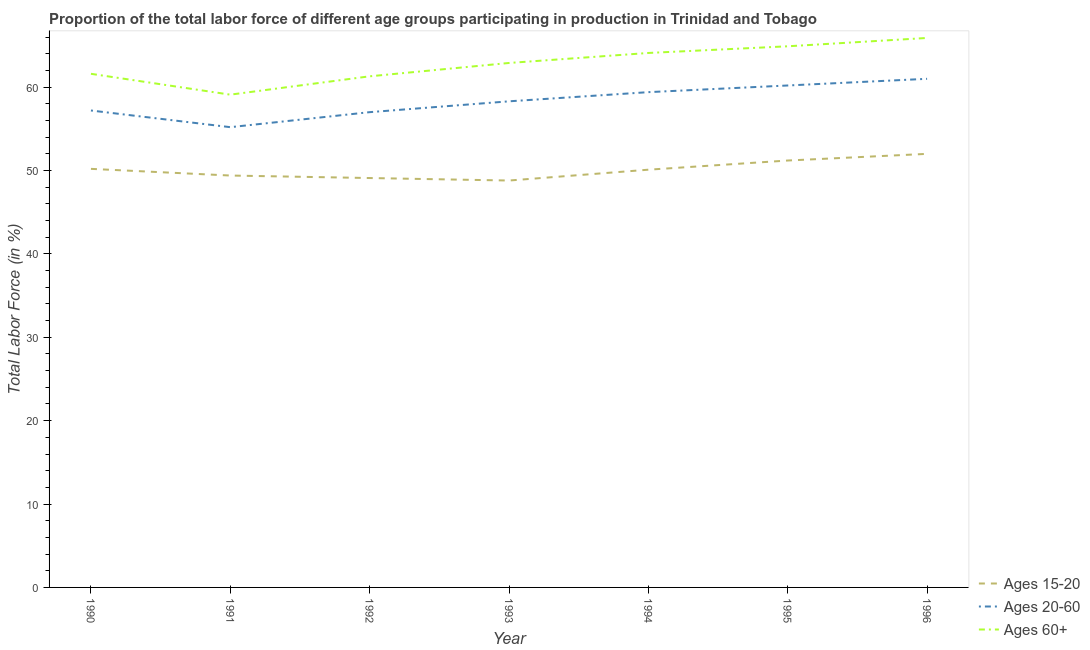How many different coloured lines are there?
Ensure brevity in your answer.  3. Does the line corresponding to percentage of labor force within the age group 20-60 intersect with the line corresponding to percentage of labor force above age 60?
Ensure brevity in your answer.  No. What is the percentage of labor force above age 60 in 1996?
Ensure brevity in your answer.  65.9. Across all years, what is the maximum percentage of labor force within the age group 20-60?
Your answer should be very brief. 61. Across all years, what is the minimum percentage of labor force above age 60?
Give a very brief answer. 59.1. In which year was the percentage of labor force within the age group 15-20 maximum?
Offer a terse response. 1996. What is the total percentage of labor force within the age group 15-20 in the graph?
Offer a very short reply. 350.8. What is the difference between the percentage of labor force within the age group 20-60 in 1995 and the percentage of labor force above age 60 in 1994?
Your response must be concise. -3.9. What is the average percentage of labor force within the age group 20-60 per year?
Provide a succinct answer. 58.33. In the year 1994, what is the difference between the percentage of labor force within the age group 15-20 and percentage of labor force above age 60?
Provide a short and direct response. -14. In how many years, is the percentage of labor force within the age group 15-20 greater than 36 %?
Offer a very short reply. 7. What is the ratio of the percentage of labor force within the age group 20-60 in 1991 to that in 1995?
Your answer should be compact. 0.92. Is the percentage of labor force within the age group 15-20 in 1990 less than that in 1991?
Keep it short and to the point. No. Is the difference between the percentage of labor force within the age group 20-60 in 1992 and 1995 greater than the difference between the percentage of labor force within the age group 15-20 in 1992 and 1995?
Provide a succinct answer. No. What is the difference between the highest and the second highest percentage of labor force above age 60?
Provide a succinct answer. 1. What is the difference between the highest and the lowest percentage of labor force within the age group 15-20?
Offer a very short reply. 3.2. Is the percentage of labor force within the age group 20-60 strictly less than the percentage of labor force within the age group 15-20 over the years?
Offer a terse response. No. How many years are there in the graph?
Your answer should be compact. 7. What is the difference between two consecutive major ticks on the Y-axis?
Offer a terse response. 10. Where does the legend appear in the graph?
Keep it short and to the point. Bottom right. How are the legend labels stacked?
Provide a short and direct response. Vertical. What is the title of the graph?
Offer a terse response. Proportion of the total labor force of different age groups participating in production in Trinidad and Tobago. What is the label or title of the X-axis?
Keep it short and to the point. Year. What is the Total Labor Force (in %) of Ages 15-20 in 1990?
Your answer should be very brief. 50.2. What is the Total Labor Force (in %) of Ages 20-60 in 1990?
Make the answer very short. 57.2. What is the Total Labor Force (in %) of Ages 60+ in 1990?
Offer a very short reply. 61.6. What is the Total Labor Force (in %) in Ages 15-20 in 1991?
Your response must be concise. 49.4. What is the Total Labor Force (in %) in Ages 20-60 in 1991?
Make the answer very short. 55.2. What is the Total Labor Force (in %) of Ages 60+ in 1991?
Provide a short and direct response. 59.1. What is the Total Labor Force (in %) of Ages 15-20 in 1992?
Give a very brief answer. 49.1. What is the Total Labor Force (in %) of Ages 60+ in 1992?
Keep it short and to the point. 61.3. What is the Total Labor Force (in %) of Ages 15-20 in 1993?
Ensure brevity in your answer.  48.8. What is the Total Labor Force (in %) in Ages 20-60 in 1993?
Offer a terse response. 58.3. What is the Total Labor Force (in %) in Ages 60+ in 1993?
Your answer should be compact. 62.9. What is the Total Labor Force (in %) of Ages 15-20 in 1994?
Offer a terse response. 50.1. What is the Total Labor Force (in %) of Ages 20-60 in 1994?
Make the answer very short. 59.4. What is the Total Labor Force (in %) in Ages 60+ in 1994?
Your answer should be very brief. 64.1. What is the Total Labor Force (in %) in Ages 15-20 in 1995?
Ensure brevity in your answer.  51.2. What is the Total Labor Force (in %) of Ages 20-60 in 1995?
Ensure brevity in your answer.  60.2. What is the Total Labor Force (in %) in Ages 60+ in 1995?
Make the answer very short. 64.9. What is the Total Labor Force (in %) in Ages 15-20 in 1996?
Provide a short and direct response. 52. What is the Total Labor Force (in %) of Ages 20-60 in 1996?
Offer a very short reply. 61. What is the Total Labor Force (in %) of Ages 60+ in 1996?
Make the answer very short. 65.9. Across all years, what is the maximum Total Labor Force (in %) in Ages 60+?
Your response must be concise. 65.9. Across all years, what is the minimum Total Labor Force (in %) of Ages 15-20?
Offer a terse response. 48.8. Across all years, what is the minimum Total Labor Force (in %) of Ages 20-60?
Give a very brief answer. 55.2. Across all years, what is the minimum Total Labor Force (in %) in Ages 60+?
Keep it short and to the point. 59.1. What is the total Total Labor Force (in %) in Ages 15-20 in the graph?
Provide a short and direct response. 350.8. What is the total Total Labor Force (in %) of Ages 20-60 in the graph?
Keep it short and to the point. 408.3. What is the total Total Labor Force (in %) of Ages 60+ in the graph?
Provide a short and direct response. 439.8. What is the difference between the Total Labor Force (in %) of Ages 15-20 in 1990 and that in 1991?
Offer a very short reply. 0.8. What is the difference between the Total Labor Force (in %) of Ages 20-60 in 1990 and that in 1991?
Offer a terse response. 2. What is the difference between the Total Labor Force (in %) in Ages 60+ in 1990 and that in 1991?
Provide a short and direct response. 2.5. What is the difference between the Total Labor Force (in %) of Ages 15-20 in 1990 and that in 1992?
Your answer should be compact. 1.1. What is the difference between the Total Labor Force (in %) of Ages 20-60 in 1990 and that in 1992?
Offer a very short reply. 0.2. What is the difference between the Total Labor Force (in %) of Ages 60+ in 1990 and that in 1993?
Your response must be concise. -1.3. What is the difference between the Total Labor Force (in %) in Ages 15-20 in 1990 and that in 1994?
Offer a very short reply. 0.1. What is the difference between the Total Labor Force (in %) of Ages 20-60 in 1990 and that in 1994?
Your response must be concise. -2.2. What is the difference between the Total Labor Force (in %) of Ages 60+ in 1990 and that in 1994?
Offer a very short reply. -2.5. What is the difference between the Total Labor Force (in %) of Ages 60+ in 1990 and that in 1995?
Make the answer very short. -3.3. What is the difference between the Total Labor Force (in %) of Ages 20-60 in 1990 and that in 1996?
Provide a short and direct response. -3.8. What is the difference between the Total Labor Force (in %) in Ages 20-60 in 1991 and that in 1992?
Give a very brief answer. -1.8. What is the difference between the Total Labor Force (in %) in Ages 60+ in 1991 and that in 1992?
Give a very brief answer. -2.2. What is the difference between the Total Labor Force (in %) in Ages 15-20 in 1991 and that in 1993?
Ensure brevity in your answer.  0.6. What is the difference between the Total Labor Force (in %) of Ages 15-20 in 1991 and that in 1994?
Ensure brevity in your answer.  -0.7. What is the difference between the Total Labor Force (in %) of Ages 20-60 in 1991 and that in 1994?
Ensure brevity in your answer.  -4.2. What is the difference between the Total Labor Force (in %) in Ages 60+ in 1991 and that in 1994?
Provide a succinct answer. -5. What is the difference between the Total Labor Force (in %) in Ages 20-60 in 1991 and that in 1995?
Your answer should be compact. -5. What is the difference between the Total Labor Force (in %) in Ages 15-20 in 1991 and that in 1996?
Offer a terse response. -2.6. What is the difference between the Total Labor Force (in %) in Ages 15-20 in 1992 and that in 1994?
Offer a very short reply. -1. What is the difference between the Total Labor Force (in %) of Ages 20-60 in 1992 and that in 1994?
Ensure brevity in your answer.  -2.4. What is the difference between the Total Labor Force (in %) of Ages 60+ in 1992 and that in 1994?
Your answer should be compact. -2.8. What is the difference between the Total Labor Force (in %) of Ages 15-20 in 1992 and that in 1995?
Offer a terse response. -2.1. What is the difference between the Total Labor Force (in %) in Ages 20-60 in 1992 and that in 1995?
Your answer should be very brief. -3.2. What is the difference between the Total Labor Force (in %) in Ages 15-20 in 1992 and that in 1996?
Your answer should be compact. -2.9. What is the difference between the Total Labor Force (in %) of Ages 20-60 in 1992 and that in 1996?
Ensure brevity in your answer.  -4. What is the difference between the Total Labor Force (in %) in Ages 60+ in 1992 and that in 1996?
Offer a very short reply. -4.6. What is the difference between the Total Labor Force (in %) in Ages 20-60 in 1993 and that in 1994?
Make the answer very short. -1.1. What is the difference between the Total Labor Force (in %) of Ages 60+ in 1993 and that in 1995?
Your answer should be very brief. -2. What is the difference between the Total Labor Force (in %) in Ages 15-20 in 1993 and that in 1996?
Your answer should be very brief. -3.2. What is the difference between the Total Labor Force (in %) of Ages 20-60 in 1993 and that in 1996?
Offer a very short reply. -2.7. What is the difference between the Total Labor Force (in %) of Ages 60+ in 1993 and that in 1996?
Your response must be concise. -3. What is the difference between the Total Labor Force (in %) in Ages 60+ in 1994 and that in 1996?
Your answer should be very brief. -1.8. What is the difference between the Total Labor Force (in %) of Ages 20-60 in 1995 and that in 1996?
Ensure brevity in your answer.  -0.8. What is the difference between the Total Labor Force (in %) of Ages 15-20 in 1990 and the Total Labor Force (in %) of Ages 20-60 in 1991?
Your answer should be compact. -5. What is the difference between the Total Labor Force (in %) in Ages 15-20 in 1990 and the Total Labor Force (in %) in Ages 60+ in 1991?
Offer a terse response. -8.9. What is the difference between the Total Labor Force (in %) in Ages 20-60 in 1990 and the Total Labor Force (in %) in Ages 60+ in 1991?
Provide a short and direct response. -1.9. What is the difference between the Total Labor Force (in %) of Ages 20-60 in 1990 and the Total Labor Force (in %) of Ages 60+ in 1992?
Provide a succinct answer. -4.1. What is the difference between the Total Labor Force (in %) in Ages 15-20 in 1990 and the Total Labor Force (in %) in Ages 20-60 in 1993?
Provide a short and direct response. -8.1. What is the difference between the Total Labor Force (in %) of Ages 15-20 in 1990 and the Total Labor Force (in %) of Ages 60+ in 1993?
Ensure brevity in your answer.  -12.7. What is the difference between the Total Labor Force (in %) in Ages 15-20 in 1990 and the Total Labor Force (in %) in Ages 20-60 in 1994?
Provide a short and direct response. -9.2. What is the difference between the Total Labor Force (in %) of Ages 15-20 in 1990 and the Total Labor Force (in %) of Ages 60+ in 1995?
Make the answer very short. -14.7. What is the difference between the Total Labor Force (in %) in Ages 20-60 in 1990 and the Total Labor Force (in %) in Ages 60+ in 1995?
Your response must be concise. -7.7. What is the difference between the Total Labor Force (in %) of Ages 15-20 in 1990 and the Total Labor Force (in %) of Ages 60+ in 1996?
Provide a succinct answer. -15.7. What is the difference between the Total Labor Force (in %) in Ages 15-20 in 1991 and the Total Labor Force (in %) in Ages 20-60 in 1992?
Offer a very short reply. -7.6. What is the difference between the Total Labor Force (in %) of Ages 15-20 in 1991 and the Total Labor Force (in %) of Ages 20-60 in 1993?
Offer a terse response. -8.9. What is the difference between the Total Labor Force (in %) of Ages 15-20 in 1991 and the Total Labor Force (in %) of Ages 60+ in 1994?
Provide a succinct answer. -14.7. What is the difference between the Total Labor Force (in %) of Ages 15-20 in 1991 and the Total Labor Force (in %) of Ages 60+ in 1995?
Your answer should be very brief. -15.5. What is the difference between the Total Labor Force (in %) of Ages 15-20 in 1991 and the Total Labor Force (in %) of Ages 60+ in 1996?
Your answer should be very brief. -16.5. What is the difference between the Total Labor Force (in %) in Ages 15-20 in 1992 and the Total Labor Force (in %) in Ages 20-60 in 1993?
Offer a very short reply. -9.2. What is the difference between the Total Labor Force (in %) in Ages 15-20 in 1992 and the Total Labor Force (in %) in Ages 60+ in 1993?
Ensure brevity in your answer.  -13.8. What is the difference between the Total Labor Force (in %) in Ages 20-60 in 1992 and the Total Labor Force (in %) in Ages 60+ in 1993?
Provide a short and direct response. -5.9. What is the difference between the Total Labor Force (in %) of Ages 15-20 in 1992 and the Total Labor Force (in %) of Ages 60+ in 1994?
Your answer should be very brief. -15. What is the difference between the Total Labor Force (in %) of Ages 20-60 in 1992 and the Total Labor Force (in %) of Ages 60+ in 1994?
Make the answer very short. -7.1. What is the difference between the Total Labor Force (in %) of Ages 15-20 in 1992 and the Total Labor Force (in %) of Ages 60+ in 1995?
Keep it short and to the point. -15.8. What is the difference between the Total Labor Force (in %) of Ages 20-60 in 1992 and the Total Labor Force (in %) of Ages 60+ in 1995?
Your response must be concise. -7.9. What is the difference between the Total Labor Force (in %) in Ages 15-20 in 1992 and the Total Labor Force (in %) in Ages 20-60 in 1996?
Give a very brief answer. -11.9. What is the difference between the Total Labor Force (in %) in Ages 15-20 in 1992 and the Total Labor Force (in %) in Ages 60+ in 1996?
Offer a terse response. -16.8. What is the difference between the Total Labor Force (in %) of Ages 20-60 in 1992 and the Total Labor Force (in %) of Ages 60+ in 1996?
Give a very brief answer. -8.9. What is the difference between the Total Labor Force (in %) in Ages 15-20 in 1993 and the Total Labor Force (in %) in Ages 20-60 in 1994?
Provide a short and direct response. -10.6. What is the difference between the Total Labor Force (in %) in Ages 15-20 in 1993 and the Total Labor Force (in %) in Ages 60+ in 1994?
Make the answer very short. -15.3. What is the difference between the Total Labor Force (in %) of Ages 20-60 in 1993 and the Total Labor Force (in %) of Ages 60+ in 1994?
Keep it short and to the point. -5.8. What is the difference between the Total Labor Force (in %) of Ages 15-20 in 1993 and the Total Labor Force (in %) of Ages 60+ in 1995?
Give a very brief answer. -16.1. What is the difference between the Total Labor Force (in %) in Ages 20-60 in 1993 and the Total Labor Force (in %) in Ages 60+ in 1995?
Offer a very short reply. -6.6. What is the difference between the Total Labor Force (in %) of Ages 15-20 in 1993 and the Total Labor Force (in %) of Ages 20-60 in 1996?
Ensure brevity in your answer.  -12.2. What is the difference between the Total Labor Force (in %) of Ages 15-20 in 1993 and the Total Labor Force (in %) of Ages 60+ in 1996?
Ensure brevity in your answer.  -17.1. What is the difference between the Total Labor Force (in %) of Ages 20-60 in 1993 and the Total Labor Force (in %) of Ages 60+ in 1996?
Ensure brevity in your answer.  -7.6. What is the difference between the Total Labor Force (in %) of Ages 15-20 in 1994 and the Total Labor Force (in %) of Ages 60+ in 1995?
Your answer should be very brief. -14.8. What is the difference between the Total Labor Force (in %) in Ages 15-20 in 1994 and the Total Labor Force (in %) in Ages 60+ in 1996?
Give a very brief answer. -15.8. What is the difference between the Total Labor Force (in %) in Ages 20-60 in 1994 and the Total Labor Force (in %) in Ages 60+ in 1996?
Ensure brevity in your answer.  -6.5. What is the difference between the Total Labor Force (in %) of Ages 15-20 in 1995 and the Total Labor Force (in %) of Ages 20-60 in 1996?
Your answer should be very brief. -9.8. What is the difference between the Total Labor Force (in %) in Ages 15-20 in 1995 and the Total Labor Force (in %) in Ages 60+ in 1996?
Provide a short and direct response. -14.7. What is the average Total Labor Force (in %) of Ages 15-20 per year?
Your answer should be very brief. 50.11. What is the average Total Labor Force (in %) in Ages 20-60 per year?
Offer a terse response. 58.33. What is the average Total Labor Force (in %) in Ages 60+ per year?
Offer a very short reply. 62.83. In the year 1990, what is the difference between the Total Labor Force (in %) in Ages 15-20 and Total Labor Force (in %) in Ages 60+?
Your answer should be very brief. -11.4. In the year 1990, what is the difference between the Total Labor Force (in %) in Ages 20-60 and Total Labor Force (in %) in Ages 60+?
Your answer should be very brief. -4.4. In the year 1991, what is the difference between the Total Labor Force (in %) in Ages 15-20 and Total Labor Force (in %) in Ages 20-60?
Your answer should be very brief. -5.8. In the year 1991, what is the difference between the Total Labor Force (in %) of Ages 20-60 and Total Labor Force (in %) of Ages 60+?
Offer a very short reply. -3.9. In the year 1992, what is the difference between the Total Labor Force (in %) in Ages 15-20 and Total Labor Force (in %) in Ages 60+?
Offer a very short reply. -12.2. In the year 1993, what is the difference between the Total Labor Force (in %) in Ages 15-20 and Total Labor Force (in %) in Ages 60+?
Your answer should be very brief. -14.1. In the year 1994, what is the difference between the Total Labor Force (in %) in Ages 15-20 and Total Labor Force (in %) in Ages 20-60?
Provide a short and direct response. -9.3. In the year 1995, what is the difference between the Total Labor Force (in %) in Ages 15-20 and Total Labor Force (in %) in Ages 60+?
Provide a short and direct response. -13.7. In the year 1996, what is the difference between the Total Labor Force (in %) in Ages 15-20 and Total Labor Force (in %) in Ages 20-60?
Give a very brief answer. -9. In the year 1996, what is the difference between the Total Labor Force (in %) in Ages 15-20 and Total Labor Force (in %) in Ages 60+?
Keep it short and to the point. -13.9. What is the ratio of the Total Labor Force (in %) of Ages 15-20 in 1990 to that in 1991?
Provide a succinct answer. 1.02. What is the ratio of the Total Labor Force (in %) in Ages 20-60 in 1990 to that in 1991?
Your answer should be compact. 1.04. What is the ratio of the Total Labor Force (in %) in Ages 60+ in 1990 to that in 1991?
Your response must be concise. 1.04. What is the ratio of the Total Labor Force (in %) in Ages 15-20 in 1990 to that in 1992?
Offer a terse response. 1.02. What is the ratio of the Total Labor Force (in %) in Ages 60+ in 1990 to that in 1992?
Ensure brevity in your answer.  1. What is the ratio of the Total Labor Force (in %) of Ages 15-20 in 1990 to that in 1993?
Give a very brief answer. 1.03. What is the ratio of the Total Labor Force (in %) in Ages 20-60 in 1990 to that in 1993?
Make the answer very short. 0.98. What is the ratio of the Total Labor Force (in %) in Ages 60+ in 1990 to that in 1993?
Offer a terse response. 0.98. What is the ratio of the Total Labor Force (in %) in Ages 15-20 in 1990 to that in 1994?
Give a very brief answer. 1. What is the ratio of the Total Labor Force (in %) of Ages 15-20 in 1990 to that in 1995?
Keep it short and to the point. 0.98. What is the ratio of the Total Labor Force (in %) of Ages 20-60 in 1990 to that in 1995?
Your answer should be very brief. 0.95. What is the ratio of the Total Labor Force (in %) of Ages 60+ in 1990 to that in 1995?
Offer a terse response. 0.95. What is the ratio of the Total Labor Force (in %) in Ages 15-20 in 1990 to that in 1996?
Keep it short and to the point. 0.97. What is the ratio of the Total Labor Force (in %) in Ages 20-60 in 1990 to that in 1996?
Keep it short and to the point. 0.94. What is the ratio of the Total Labor Force (in %) in Ages 60+ in 1990 to that in 1996?
Make the answer very short. 0.93. What is the ratio of the Total Labor Force (in %) in Ages 15-20 in 1991 to that in 1992?
Provide a succinct answer. 1.01. What is the ratio of the Total Labor Force (in %) in Ages 20-60 in 1991 to that in 1992?
Ensure brevity in your answer.  0.97. What is the ratio of the Total Labor Force (in %) in Ages 60+ in 1991 to that in 1992?
Make the answer very short. 0.96. What is the ratio of the Total Labor Force (in %) in Ages 15-20 in 1991 to that in 1993?
Your response must be concise. 1.01. What is the ratio of the Total Labor Force (in %) of Ages 20-60 in 1991 to that in 1993?
Ensure brevity in your answer.  0.95. What is the ratio of the Total Labor Force (in %) in Ages 60+ in 1991 to that in 1993?
Offer a very short reply. 0.94. What is the ratio of the Total Labor Force (in %) in Ages 15-20 in 1991 to that in 1994?
Your response must be concise. 0.99. What is the ratio of the Total Labor Force (in %) in Ages 20-60 in 1991 to that in 1994?
Your answer should be compact. 0.93. What is the ratio of the Total Labor Force (in %) of Ages 60+ in 1991 to that in 1994?
Make the answer very short. 0.92. What is the ratio of the Total Labor Force (in %) in Ages 15-20 in 1991 to that in 1995?
Offer a very short reply. 0.96. What is the ratio of the Total Labor Force (in %) in Ages 20-60 in 1991 to that in 1995?
Your answer should be compact. 0.92. What is the ratio of the Total Labor Force (in %) of Ages 60+ in 1991 to that in 1995?
Make the answer very short. 0.91. What is the ratio of the Total Labor Force (in %) in Ages 15-20 in 1991 to that in 1996?
Your answer should be compact. 0.95. What is the ratio of the Total Labor Force (in %) of Ages 20-60 in 1991 to that in 1996?
Offer a terse response. 0.9. What is the ratio of the Total Labor Force (in %) in Ages 60+ in 1991 to that in 1996?
Your answer should be very brief. 0.9. What is the ratio of the Total Labor Force (in %) of Ages 20-60 in 1992 to that in 1993?
Offer a terse response. 0.98. What is the ratio of the Total Labor Force (in %) of Ages 60+ in 1992 to that in 1993?
Your answer should be very brief. 0.97. What is the ratio of the Total Labor Force (in %) in Ages 20-60 in 1992 to that in 1994?
Ensure brevity in your answer.  0.96. What is the ratio of the Total Labor Force (in %) of Ages 60+ in 1992 to that in 1994?
Provide a succinct answer. 0.96. What is the ratio of the Total Labor Force (in %) of Ages 15-20 in 1992 to that in 1995?
Ensure brevity in your answer.  0.96. What is the ratio of the Total Labor Force (in %) in Ages 20-60 in 1992 to that in 1995?
Provide a succinct answer. 0.95. What is the ratio of the Total Labor Force (in %) of Ages 60+ in 1992 to that in 1995?
Offer a very short reply. 0.94. What is the ratio of the Total Labor Force (in %) in Ages 15-20 in 1992 to that in 1996?
Make the answer very short. 0.94. What is the ratio of the Total Labor Force (in %) of Ages 20-60 in 1992 to that in 1996?
Provide a short and direct response. 0.93. What is the ratio of the Total Labor Force (in %) of Ages 60+ in 1992 to that in 1996?
Ensure brevity in your answer.  0.93. What is the ratio of the Total Labor Force (in %) of Ages 15-20 in 1993 to that in 1994?
Provide a short and direct response. 0.97. What is the ratio of the Total Labor Force (in %) of Ages 20-60 in 1993 to that in 1994?
Offer a very short reply. 0.98. What is the ratio of the Total Labor Force (in %) of Ages 60+ in 1993 to that in 1994?
Ensure brevity in your answer.  0.98. What is the ratio of the Total Labor Force (in %) of Ages 15-20 in 1993 to that in 1995?
Keep it short and to the point. 0.95. What is the ratio of the Total Labor Force (in %) in Ages 20-60 in 1993 to that in 1995?
Make the answer very short. 0.97. What is the ratio of the Total Labor Force (in %) of Ages 60+ in 1993 to that in 1995?
Keep it short and to the point. 0.97. What is the ratio of the Total Labor Force (in %) of Ages 15-20 in 1993 to that in 1996?
Give a very brief answer. 0.94. What is the ratio of the Total Labor Force (in %) in Ages 20-60 in 1993 to that in 1996?
Your answer should be compact. 0.96. What is the ratio of the Total Labor Force (in %) in Ages 60+ in 1993 to that in 1996?
Keep it short and to the point. 0.95. What is the ratio of the Total Labor Force (in %) of Ages 15-20 in 1994 to that in 1995?
Provide a succinct answer. 0.98. What is the ratio of the Total Labor Force (in %) in Ages 20-60 in 1994 to that in 1995?
Offer a very short reply. 0.99. What is the ratio of the Total Labor Force (in %) in Ages 60+ in 1994 to that in 1995?
Offer a very short reply. 0.99. What is the ratio of the Total Labor Force (in %) of Ages 15-20 in 1994 to that in 1996?
Provide a short and direct response. 0.96. What is the ratio of the Total Labor Force (in %) of Ages 20-60 in 1994 to that in 1996?
Your answer should be compact. 0.97. What is the ratio of the Total Labor Force (in %) in Ages 60+ in 1994 to that in 1996?
Provide a succinct answer. 0.97. What is the ratio of the Total Labor Force (in %) of Ages 15-20 in 1995 to that in 1996?
Your answer should be very brief. 0.98. What is the ratio of the Total Labor Force (in %) of Ages 20-60 in 1995 to that in 1996?
Give a very brief answer. 0.99. What is the ratio of the Total Labor Force (in %) in Ages 60+ in 1995 to that in 1996?
Offer a very short reply. 0.98. What is the difference between the highest and the second highest Total Labor Force (in %) in Ages 15-20?
Your response must be concise. 0.8. What is the difference between the highest and the second highest Total Labor Force (in %) in Ages 60+?
Ensure brevity in your answer.  1. What is the difference between the highest and the lowest Total Labor Force (in %) of Ages 15-20?
Your response must be concise. 3.2. 